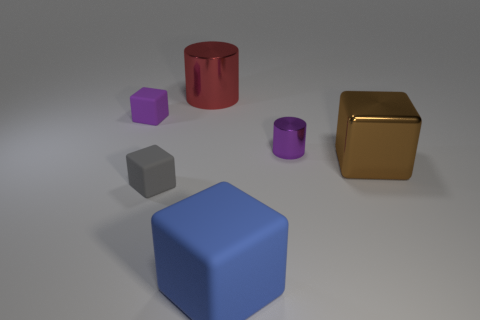Add 2 purple rubber things. How many objects exist? 8 Subtract all blocks. How many objects are left? 2 Add 5 shiny objects. How many shiny objects are left? 8 Add 2 matte objects. How many matte objects exist? 5 Subtract 1 purple cubes. How many objects are left? 5 Subtract all blue objects. Subtract all small blocks. How many objects are left? 3 